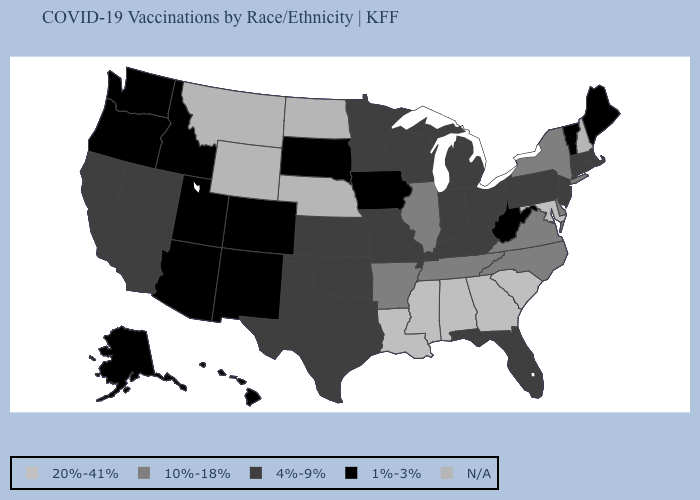What is the value of Kansas?
Concise answer only. 4%-9%. Does Indiana have the highest value in the MidWest?
Give a very brief answer. No. Is the legend a continuous bar?
Be succinct. No. Among the states that border Tennessee , does Kentucky have the lowest value?
Answer briefly. Yes. Which states have the lowest value in the USA?
Answer briefly. Alaska, Arizona, Colorado, Hawaii, Idaho, Iowa, Maine, New Mexico, Oregon, South Dakota, Utah, Vermont, Washington, West Virginia. Name the states that have a value in the range 4%-9%?
Write a very short answer. California, Connecticut, Florida, Indiana, Kansas, Kentucky, Massachusetts, Michigan, Minnesota, Missouri, Nevada, New Jersey, Ohio, Oklahoma, Pennsylvania, Rhode Island, Texas, Wisconsin. Does the first symbol in the legend represent the smallest category?
Write a very short answer. No. What is the highest value in the Northeast ?
Keep it brief. 10%-18%. Name the states that have a value in the range 10%-18%?
Keep it brief. Arkansas, Delaware, Illinois, New York, North Carolina, Tennessee, Virginia. Among the states that border Rhode Island , which have the lowest value?
Answer briefly. Connecticut, Massachusetts. What is the highest value in the West ?
Quick response, please. 4%-9%. 